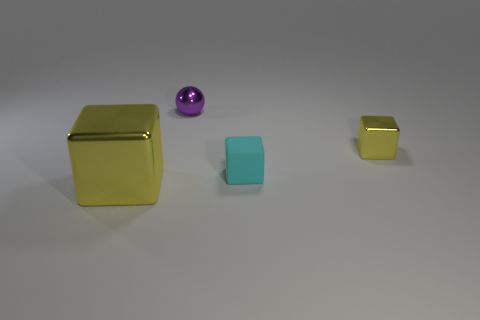Add 4 cubes. How many objects exist? 8 Subtract all balls. How many objects are left? 3 Add 1 tiny yellow shiny blocks. How many tiny yellow shiny blocks exist? 2 Subtract 1 purple spheres. How many objects are left? 3 Subtract all big cyan shiny balls. Subtract all big blocks. How many objects are left? 3 Add 4 small yellow objects. How many small yellow objects are left? 5 